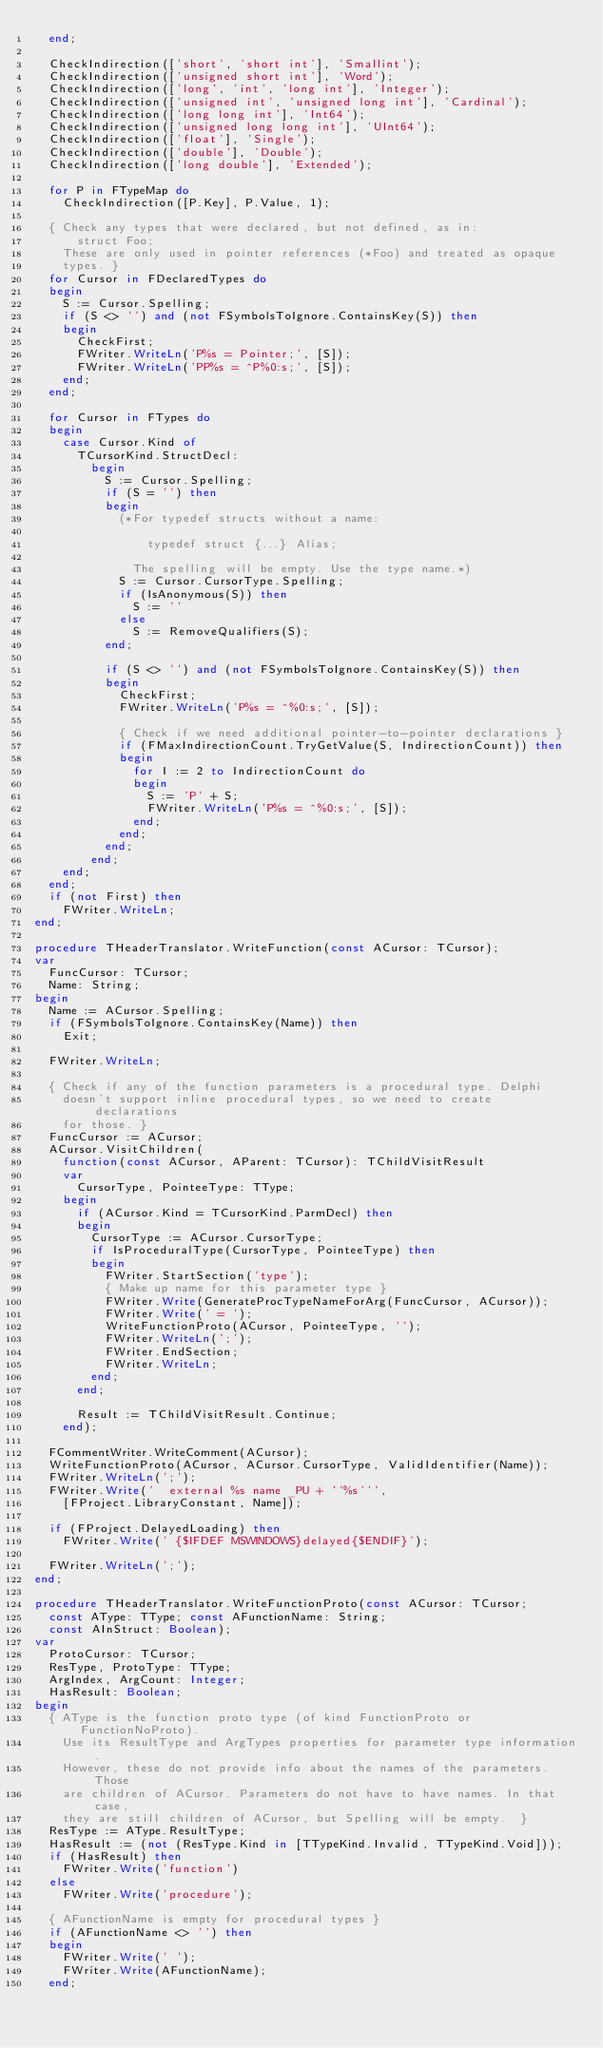Convert code to text. <code><loc_0><loc_0><loc_500><loc_500><_Pascal_>  end;

  CheckIndirection(['short', 'short int'], 'Smallint');
  CheckIndirection(['unsigned short int'], 'Word');
  CheckIndirection(['long', 'int', 'long int'], 'Integer');
  CheckIndirection(['unsigned int', 'unsigned long int'], 'Cardinal');
  CheckIndirection(['long long int'], 'Int64');
  CheckIndirection(['unsigned long long int'], 'UInt64');
  CheckIndirection(['float'], 'Single');
  CheckIndirection(['double'], 'Double');
  CheckIndirection(['long double'], 'Extended');

  for P in FTypeMap do
    CheckIndirection([P.Key], P.Value, 1);

  { Check any types that were declared, but not defined, as in:
      struct Foo;
    These are only used in pointer references (*Foo) and treated as opaque
    types. }
  for Cursor in FDeclaredTypes do
  begin
    S := Cursor.Spelling;
    if (S <> '') and (not FSymbolsToIgnore.ContainsKey(S)) then
    begin
      CheckFirst;
      FWriter.WriteLn('P%s = Pointer;', [S]);
      FWriter.WriteLn('PP%s = ^P%0:s;', [S]);
    end;
  end;

  for Cursor in FTypes do
  begin
    case Cursor.Kind of
      TCursorKind.StructDecl:
        begin
          S := Cursor.Spelling;
          if (S = '') then
          begin
            (*For typedef structs without a name:

                typedef struct {...} Alias;

              The spelling will be empty. Use the type name.*)
            S := Cursor.CursorType.Spelling;
            if (IsAnonymous(S)) then
              S := ''
            else
              S := RemoveQualifiers(S);
          end;

          if (S <> '') and (not FSymbolsToIgnore.ContainsKey(S)) then
          begin
            CheckFirst;
            FWriter.WriteLn('P%s = ^%0:s;', [S]);

            { Check if we need additional pointer-to-pointer declarations }
            if (FMaxIndirectionCount.TryGetValue(S, IndirectionCount)) then
            begin
              for I := 2 to IndirectionCount do
              begin
                S := 'P' + S;
                FWriter.WriteLn('P%s = ^%0:s;', [S]);
              end;
            end;
          end;
        end;
    end;
  end;
  if (not First) then
    FWriter.WriteLn;
end;

procedure THeaderTranslator.WriteFunction(const ACursor: TCursor);
var
  FuncCursor: TCursor;
  Name: String;
begin
  Name := ACursor.Spelling;
  if (FSymbolsToIgnore.ContainsKey(Name)) then
    Exit;

  FWriter.WriteLn;

  { Check if any of the function parameters is a procedural type. Delphi
    doesn't support inline procedural types, so we need to create declarations
    for those. }
  FuncCursor := ACursor;
  ACursor.VisitChildren(
    function(const ACursor, AParent: TCursor): TChildVisitResult
    var
      CursorType, PointeeType: TType;
    begin
      if (ACursor.Kind = TCursorKind.ParmDecl) then
      begin
        CursorType := ACursor.CursorType;
        if IsProceduralType(CursorType, PointeeType) then
        begin
          FWriter.StartSection('type');
          { Make up name for this parameter type }
          FWriter.Write(GenerateProcTypeNameForArg(FuncCursor, ACursor));
          FWriter.Write(' = ');
          WriteFunctionProto(ACursor, PointeeType, '');
          FWriter.WriteLn(';');
          FWriter.EndSection;
          FWriter.WriteLn;
        end;
      end;

      Result := TChildVisitResult.Continue;
    end);

  FCommentWriter.WriteComment(ACursor);
  WriteFunctionProto(ACursor, ACursor.CursorType, ValidIdentifier(Name));
  FWriter.WriteLn(';');
  FWriter.Write('  external %s name _PU + ''%s''',
    [FProject.LibraryConstant, Name]);

  if (FProject.DelayedLoading) then
    FWriter.Write(' {$IFDEF MSWINDOWS}delayed{$ENDIF}');

  FWriter.WriteLn(';');
end;

procedure THeaderTranslator.WriteFunctionProto(const ACursor: TCursor;
  const AType: TType; const AFunctionName: String;
  const AInStruct: Boolean);
var
  ProtoCursor: TCursor;
  ResType, ProtoType: TType;
  ArgIndex, ArgCount: Integer;
  HasResult: Boolean;
begin
  { AType is the function proto type (of kind FunctionProto or FunctionNoProto).
    Use its ResultType and ArgTypes properties for parameter type information.
    However, these do not provide info about the names of the parameters. Those
    are children of ACursor. Parameters do not have to have names. In that case,
    they are still children of ACursor, but Spelling will be empty.  }
  ResType := AType.ResultType;
  HasResult := (not (ResType.Kind in [TTypeKind.Invalid, TTypeKind.Void]));
  if (HasResult) then
    FWriter.Write('function')
  else
    FWriter.Write('procedure');

  { AFunctionName is empty for procedural types }
  if (AFunctionName <> '') then
  begin
    FWriter.Write(' ');
    FWriter.Write(AFunctionName);
  end;
</code> 